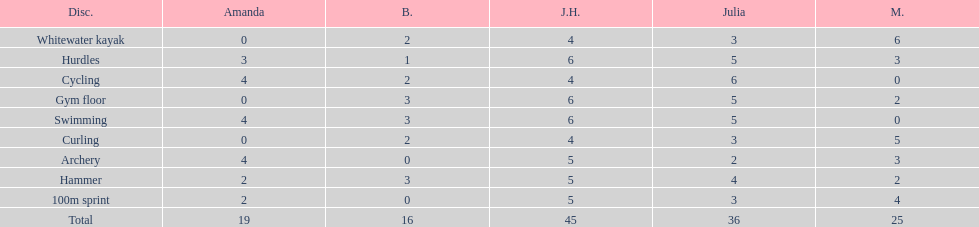What is the average score on 100m sprint? 2.8. Could you parse the entire table as a dict? {'header': ['Disc.', 'Amanda', 'B.', 'J.H.', 'Julia', 'M.'], 'rows': [['Whitewater kayak', '0', '2', '4', '3', '6'], ['Hurdles', '3', '1', '6', '5', '3'], ['Cycling', '4', '2', '4', '6', '0'], ['Gym floor', '0', '3', '6', '5', '2'], ['Swimming', '4', '3', '6', '5', '0'], ['Curling', '0', '2', '4', '3', '5'], ['Archery', '4', '0', '5', '2', '3'], ['Hammer', '2', '3', '5', '4', '2'], ['100m sprint', '2', '0', '5', '3', '4'], ['Total', '19', '16', '45', '36', '25']]} 